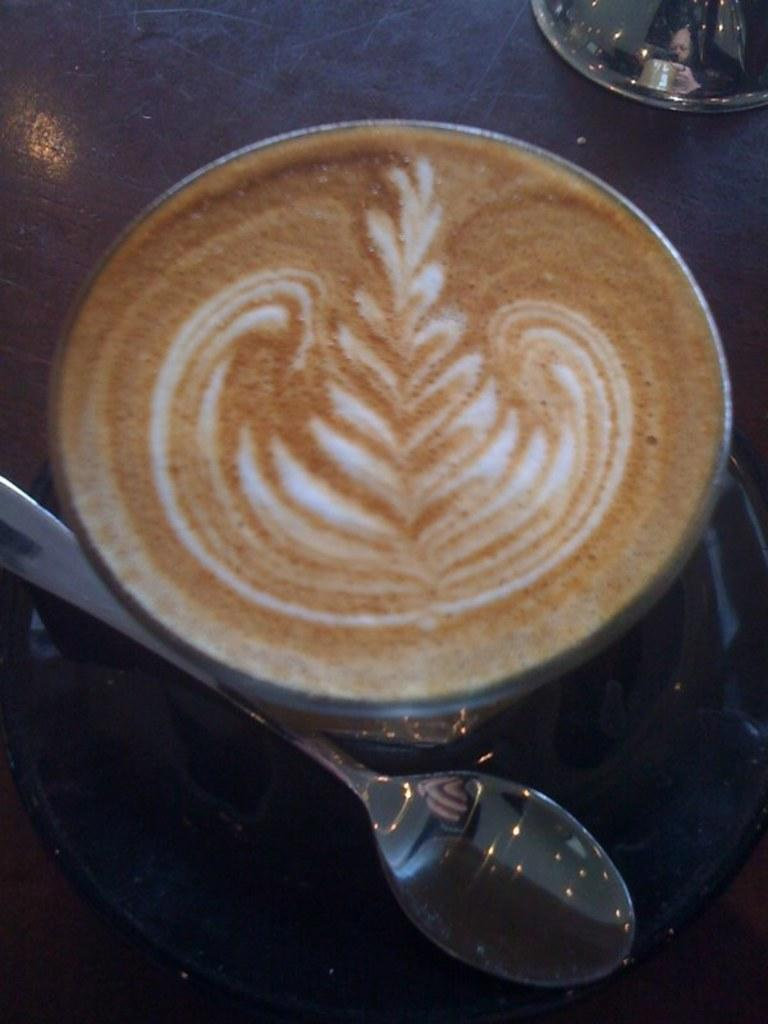What is present on the table in the image? There is a coffee cup and a spoon on the table in the image. What might be used to stir the contents of the coffee cup? The spoon in the image can be used to stir the contents of the coffee cup. What invention is being used by the manager in the image? There is no manager or invention present in the image; it only features a coffee cup and a spoon on a table. 